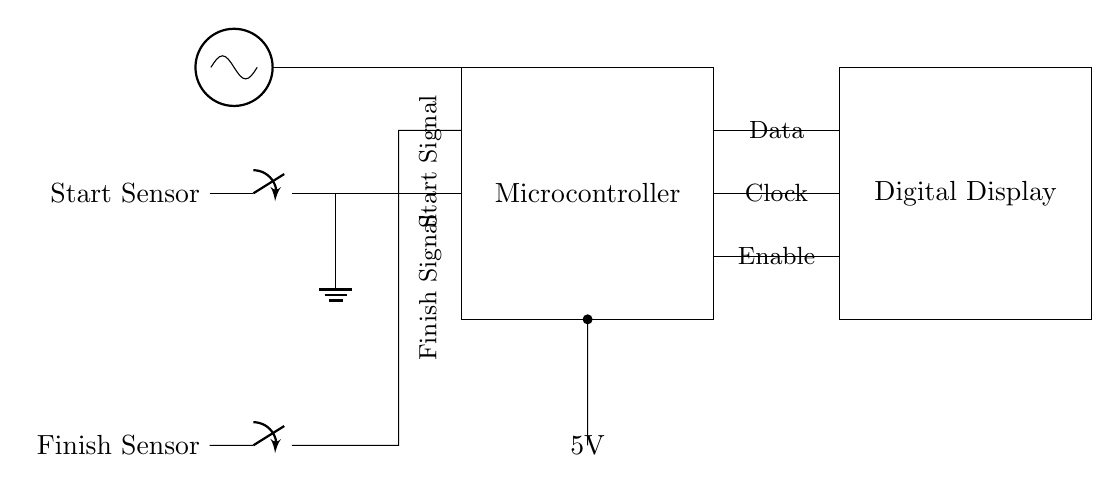What is the power supply voltage? The power supply voltage is labeled as 5V in the circuit diagram, which indicates the voltage provided to the microcontroller and other components.
Answer: 5V What is the function of the microcontroller in this circuit? The microcontroller processes the signals from the start and finish sensors and manages the timing logic for the sprint race, including sending data to the digital display.
Answer: Timing control How many sensors are in this circuit? There are two sensors: a start sensor and a finish sensor, as indicated in the circuit diagram.
Answer: Two What component provides the clock signal? The clock signal is provided by the oscillator, which is depicted at the top of the circuit diagram and connects to the microcontroller.
Answer: Oscillator Which component controls the start and finish signals? The microcontroller controls both the start and finish signals by receiving inputs from the respective sensors and processing them accordingly.
Answer: Microcontroller What is the role of the digital display in this setup? The digital display shows the timing information processed by the microcontroller, providing an output view of the race timing to the users.
Answer: Display timing 